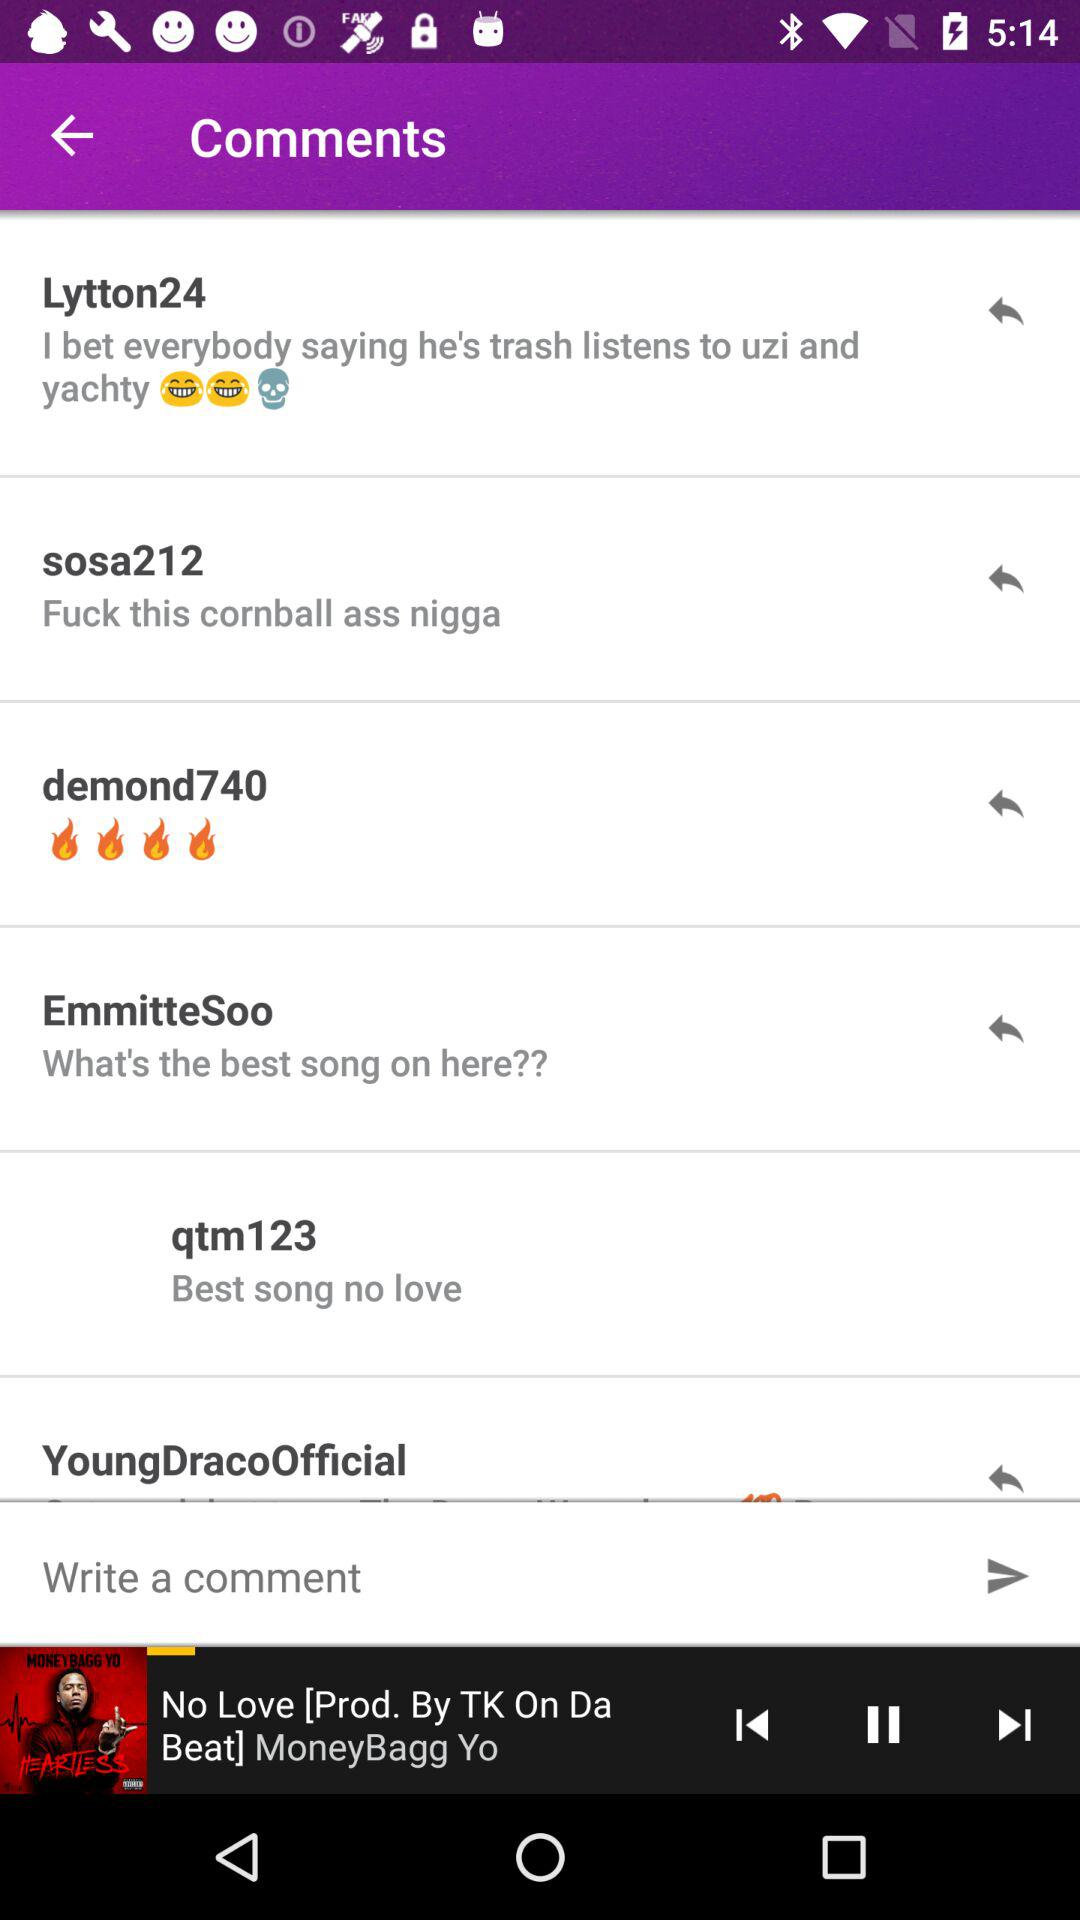What comments did "Lytton24" post? The comment is "I bet everybody saying he's trash listens to uzi and yachty". 